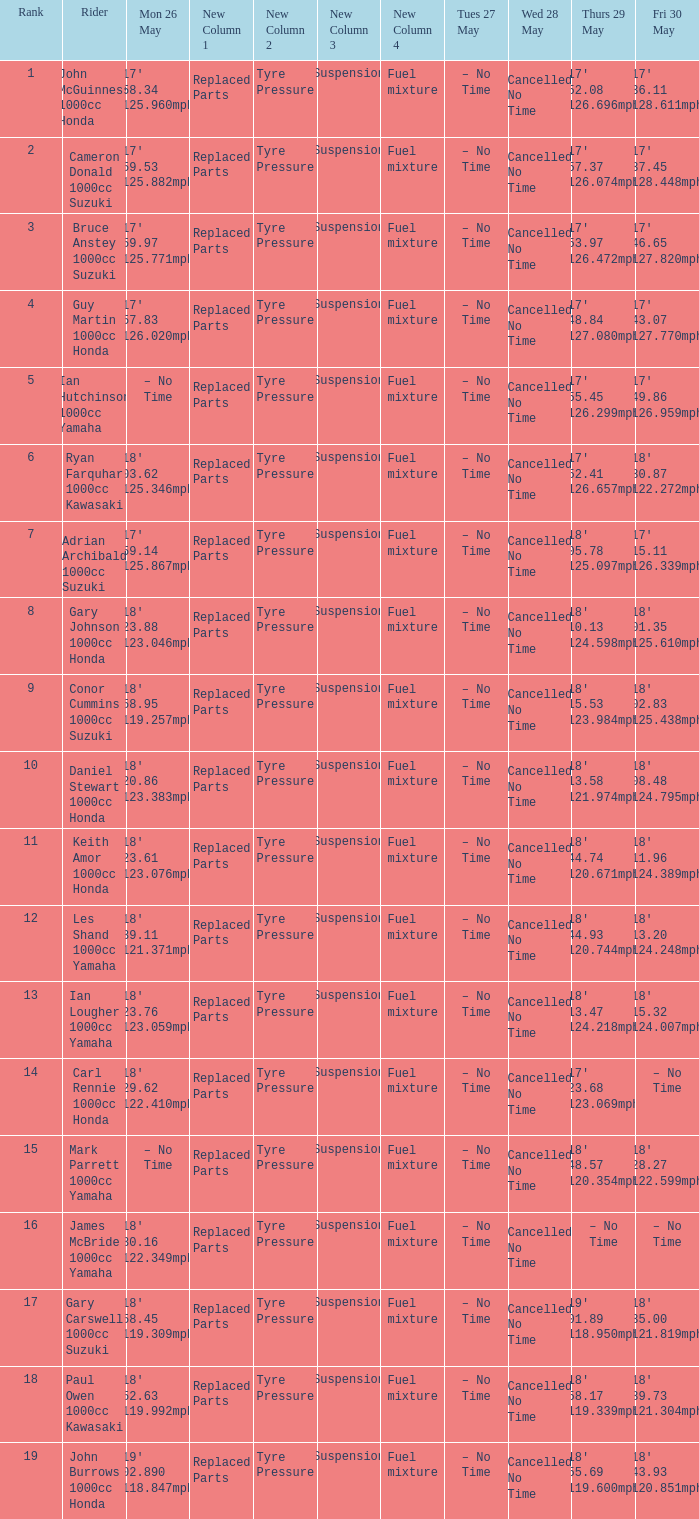What time is mon may 26 and fri may 30 is 18' 28.27 122.599mph? – No Time. 